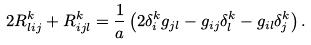<formula> <loc_0><loc_0><loc_500><loc_500>2 R ^ { k } _ { l i j } + R ^ { k } _ { i j l } = \frac { 1 } { a } \left ( 2 \delta _ { i } ^ { k } g _ { j l } - g _ { i j } \delta ^ { k } _ { l } - g _ { i l } \delta _ { j } ^ { k } \right ) .</formula> 